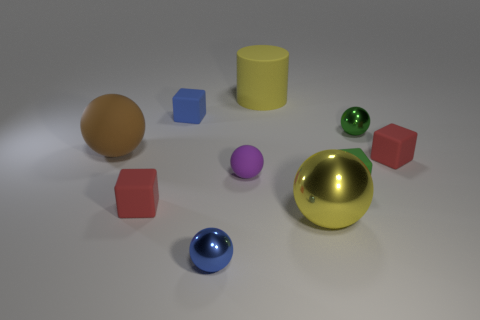Subtract all blue metallic spheres. How many spheres are left? 4 Subtract all brown balls. How many balls are left? 4 Subtract all red spheres. Subtract all blue cylinders. How many spheres are left? 5 Subtract all blocks. How many objects are left? 6 Add 4 large rubber balls. How many large rubber balls exist? 5 Subtract 0 cyan balls. How many objects are left? 10 Subtract all large things. Subtract all small blue blocks. How many objects are left? 6 Add 4 brown balls. How many brown balls are left? 5 